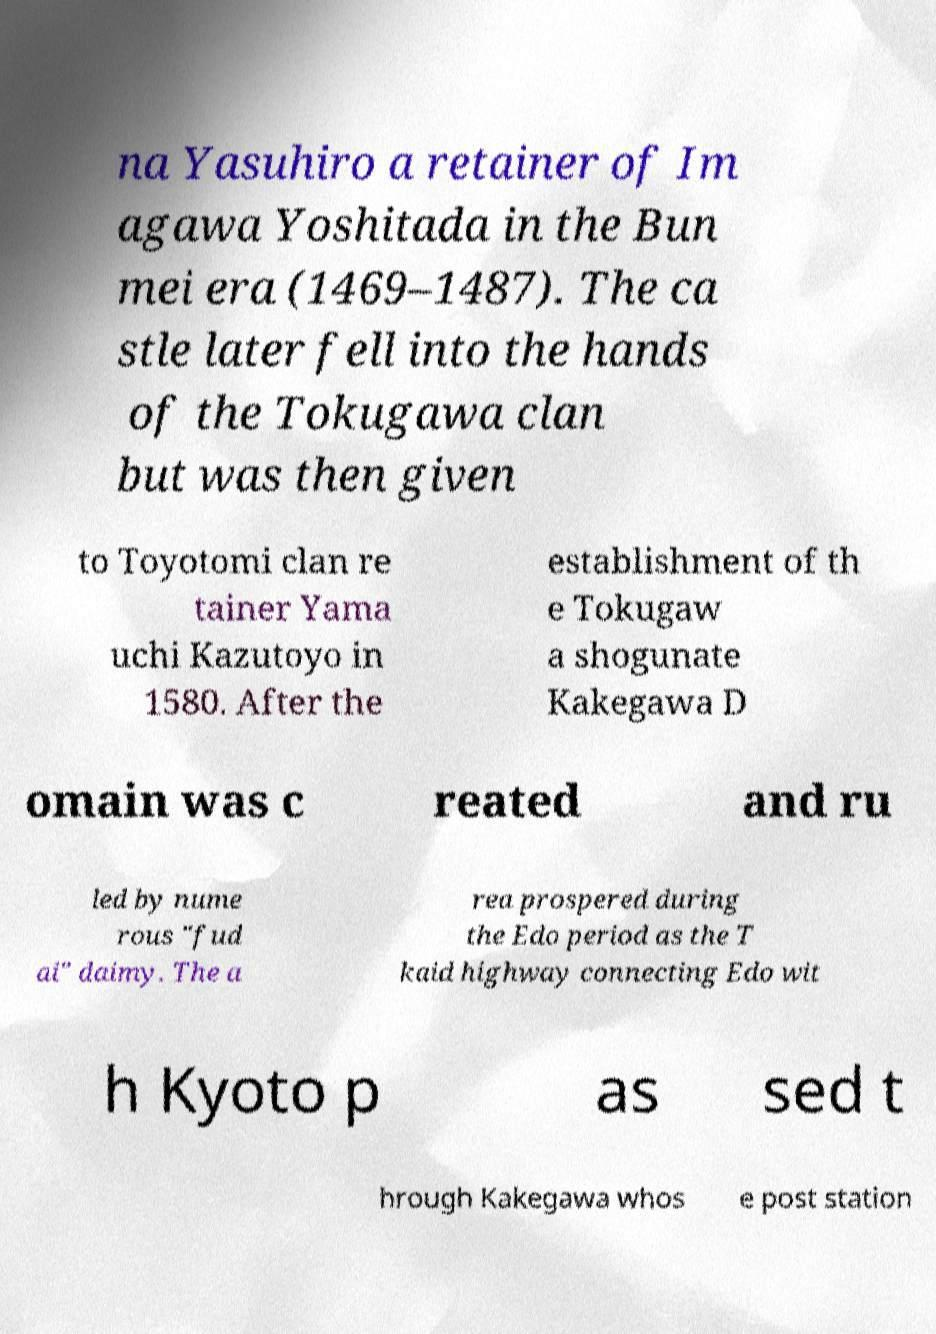Can you read and provide the text displayed in the image?This photo seems to have some interesting text. Can you extract and type it out for me? na Yasuhiro a retainer of Im agawa Yoshitada in the Bun mei era (1469–1487). The ca stle later fell into the hands of the Tokugawa clan but was then given to Toyotomi clan re tainer Yama uchi Kazutoyo in 1580. After the establishment of th e Tokugaw a shogunate Kakegawa D omain was c reated and ru led by nume rous "fud ai" daimy. The a rea prospered during the Edo period as the T kaid highway connecting Edo wit h Kyoto p as sed t hrough Kakegawa whos e post station 